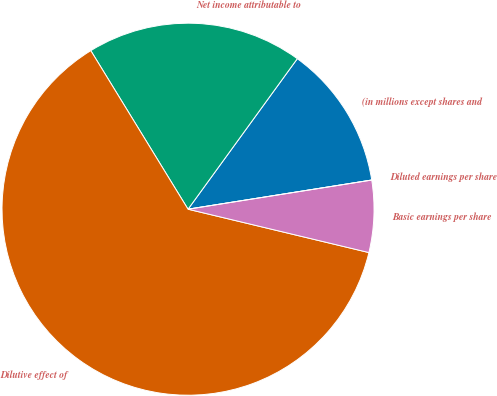Convert chart. <chart><loc_0><loc_0><loc_500><loc_500><pie_chart><fcel>(in millions except shares and<fcel>Net income attributable to<fcel>Dilutive effect of<fcel>Basic earnings per share<fcel>Diluted earnings per share<nl><fcel>12.5%<fcel>18.75%<fcel>62.5%<fcel>6.25%<fcel>0.0%<nl></chart> 